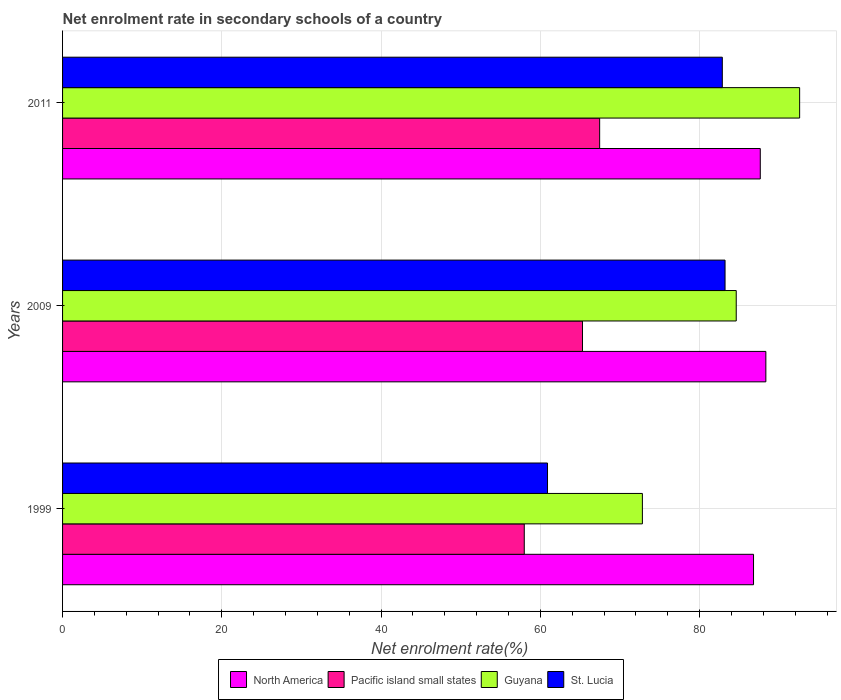How many different coloured bars are there?
Offer a terse response. 4. How many groups of bars are there?
Provide a succinct answer. 3. Are the number of bars per tick equal to the number of legend labels?
Ensure brevity in your answer.  Yes. What is the net enrolment rate in secondary schools in Guyana in 2009?
Offer a very short reply. 84.6. Across all years, what is the maximum net enrolment rate in secondary schools in North America?
Your answer should be very brief. 88.32. Across all years, what is the minimum net enrolment rate in secondary schools in Guyana?
Ensure brevity in your answer.  72.81. In which year was the net enrolment rate in secondary schools in North America minimum?
Your response must be concise. 1999. What is the total net enrolment rate in secondary schools in Guyana in the graph?
Your answer should be very brief. 249.98. What is the difference between the net enrolment rate in secondary schools in St. Lucia in 1999 and that in 2011?
Provide a succinct answer. -21.95. What is the difference between the net enrolment rate in secondary schools in Guyana in 2009 and the net enrolment rate in secondary schools in North America in 1999?
Ensure brevity in your answer.  -2.17. What is the average net enrolment rate in secondary schools in St. Lucia per year?
Provide a short and direct response. 75.65. In the year 2009, what is the difference between the net enrolment rate in secondary schools in Guyana and net enrolment rate in secondary schools in Pacific island small states?
Offer a terse response. 19.31. What is the ratio of the net enrolment rate in secondary schools in Pacific island small states in 1999 to that in 2011?
Your answer should be very brief. 0.86. What is the difference between the highest and the second highest net enrolment rate in secondary schools in Guyana?
Give a very brief answer. 7.96. What is the difference between the highest and the lowest net enrolment rate in secondary schools in St. Lucia?
Ensure brevity in your answer.  22.3. Is the sum of the net enrolment rate in secondary schools in North America in 1999 and 2011 greater than the maximum net enrolment rate in secondary schools in Guyana across all years?
Provide a short and direct response. Yes. What does the 3rd bar from the top in 2009 represents?
Keep it short and to the point. Pacific island small states. What does the 2nd bar from the bottom in 1999 represents?
Keep it short and to the point. Pacific island small states. Is it the case that in every year, the sum of the net enrolment rate in secondary schools in St. Lucia and net enrolment rate in secondary schools in Guyana is greater than the net enrolment rate in secondary schools in North America?
Provide a succinct answer. Yes. Are all the bars in the graph horizontal?
Give a very brief answer. Yes. Are the values on the major ticks of X-axis written in scientific E-notation?
Provide a short and direct response. No. Does the graph contain grids?
Your answer should be compact. Yes. Where does the legend appear in the graph?
Offer a very short reply. Bottom center. How many legend labels are there?
Make the answer very short. 4. What is the title of the graph?
Your response must be concise. Net enrolment rate in secondary schools of a country. What is the label or title of the X-axis?
Offer a terse response. Net enrolment rate(%). What is the Net enrolment rate(%) in North America in 1999?
Make the answer very short. 86.77. What is the Net enrolment rate(%) in Pacific island small states in 1999?
Your response must be concise. 57.98. What is the Net enrolment rate(%) in Guyana in 1999?
Your response must be concise. 72.81. What is the Net enrolment rate(%) in St. Lucia in 1999?
Provide a succinct answer. 60.9. What is the Net enrolment rate(%) of North America in 2009?
Ensure brevity in your answer.  88.32. What is the Net enrolment rate(%) of Pacific island small states in 2009?
Ensure brevity in your answer.  65.29. What is the Net enrolment rate(%) in Guyana in 2009?
Offer a terse response. 84.6. What is the Net enrolment rate(%) of St. Lucia in 2009?
Give a very brief answer. 83.2. What is the Net enrolment rate(%) of North America in 2011?
Give a very brief answer. 87.62. What is the Net enrolment rate(%) in Pacific island small states in 2011?
Give a very brief answer. 67.45. What is the Net enrolment rate(%) in Guyana in 2011?
Your answer should be very brief. 92.56. What is the Net enrolment rate(%) in St. Lucia in 2011?
Provide a short and direct response. 82.85. Across all years, what is the maximum Net enrolment rate(%) of North America?
Make the answer very short. 88.32. Across all years, what is the maximum Net enrolment rate(%) of Pacific island small states?
Offer a very short reply. 67.45. Across all years, what is the maximum Net enrolment rate(%) of Guyana?
Your answer should be very brief. 92.56. Across all years, what is the maximum Net enrolment rate(%) of St. Lucia?
Keep it short and to the point. 83.2. Across all years, what is the minimum Net enrolment rate(%) in North America?
Your answer should be very brief. 86.77. Across all years, what is the minimum Net enrolment rate(%) in Pacific island small states?
Offer a very short reply. 57.98. Across all years, what is the minimum Net enrolment rate(%) of Guyana?
Make the answer very short. 72.81. Across all years, what is the minimum Net enrolment rate(%) of St. Lucia?
Offer a very short reply. 60.9. What is the total Net enrolment rate(%) in North America in the graph?
Provide a short and direct response. 262.71. What is the total Net enrolment rate(%) of Pacific island small states in the graph?
Make the answer very short. 190.72. What is the total Net enrolment rate(%) of Guyana in the graph?
Your answer should be compact. 249.98. What is the total Net enrolment rate(%) of St. Lucia in the graph?
Your answer should be compact. 226.95. What is the difference between the Net enrolment rate(%) of North America in 1999 and that in 2009?
Offer a very short reply. -1.55. What is the difference between the Net enrolment rate(%) in Pacific island small states in 1999 and that in 2009?
Ensure brevity in your answer.  -7.31. What is the difference between the Net enrolment rate(%) in Guyana in 1999 and that in 2009?
Offer a very short reply. -11.79. What is the difference between the Net enrolment rate(%) in St. Lucia in 1999 and that in 2009?
Provide a short and direct response. -22.3. What is the difference between the Net enrolment rate(%) in North America in 1999 and that in 2011?
Keep it short and to the point. -0.85. What is the difference between the Net enrolment rate(%) in Pacific island small states in 1999 and that in 2011?
Your answer should be very brief. -9.47. What is the difference between the Net enrolment rate(%) of Guyana in 1999 and that in 2011?
Offer a terse response. -19.75. What is the difference between the Net enrolment rate(%) of St. Lucia in 1999 and that in 2011?
Offer a terse response. -21.95. What is the difference between the Net enrolment rate(%) in North America in 2009 and that in 2011?
Make the answer very short. 0.7. What is the difference between the Net enrolment rate(%) of Pacific island small states in 2009 and that in 2011?
Your answer should be very brief. -2.16. What is the difference between the Net enrolment rate(%) in Guyana in 2009 and that in 2011?
Your response must be concise. -7.96. What is the difference between the Net enrolment rate(%) in St. Lucia in 2009 and that in 2011?
Offer a very short reply. 0.34. What is the difference between the Net enrolment rate(%) of North America in 1999 and the Net enrolment rate(%) of Pacific island small states in 2009?
Offer a very short reply. 21.48. What is the difference between the Net enrolment rate(%) of North America in 1999 and the Net enrolment rate(%) of Guyana in 2009?
Make the answer very short. 2.17. What is the difference between the Net enrolment rate(%) of North America in 1999 and the Net enrolment rate(%) of St. Lucia in 2009?
Make the answer very short. 3.58. What is the difference between the Net enrolment rate(%) of Pacific island small states in 1999 and the Net enrolment rate(%) of Guyana in 2009?
Offer a terse response. -26.62. What is the difference between the Net enrolment rate(%) of Pacific island small states in 1999 and the Net enrolment rate(%) of St. Lucia in 2009?
Your response must be concise. -25.21. What is the difference between the Net enrolment rate(%) in Guyana in 1999 and the Net enrolment rate(%) in St. Lucia in 2009?
Your answer should be very brief. -10.38. What is the difference between the Net enrolment rate(%) in North America in 1999 and the Net enrolment rate(%) in Pacific island small states in 2011?
Give a very brief answer. 19.32. What is the difference between the Net enrolment rate(%) in North America in 1999 and the Net enrolment rate(%) in Guyana in 2011?
Give a very brief answer. -5.79. What is the difference between the Net enrolment rate(%) of North America in 1999 and the Net enrolment rate(%) of St. Lucia in 2011?
Offer a very short reply. 3.92. What is the difference between the Net enrolment rate(%) of Pacific island small states in 1999 and the Net enrolment rate(%) of Guyana in 2011?
Your answer should be compact. -34.58. What is the difference between the Net enrolment rate(%) of Pacific island small states in 1999 and the Net enrolment rate(%) of St. Lucia in 2011?
Provide a succinct answer. -24.87. What is the difference between the Net enrolment rate(%) in Guyana in 1999 and the Net enrolment rate(%) in St. Lucia in 2011?
Keep it short and to the point. -10.04. What is the difference between the Net enrolment rate(%) in North America in 2009 and the Net enrolment rate(%) in Pacific island small states in 2011?
Offer a terse response. 20.87. What is the difference between the Net enrolment rate(%) of North America in 2009 and the Net enrolment rate(%) of Guyana in 2011?
Offer a terse response. -4.24. What is the difference between the Net enrolment rate(%) in North America in 2009 and the Net enrolment rate(%) in St. Lucia in 2011?
Offer a very short reply. 5.47. What is the difference between the Net enrolment rate(%) in Pacific island small states in 2009 and the Net enrolment rate(%) in Guyana in 2011?
Provide a succinct answer. -27.27. What is the difference between the Net enrolment rate(%) of Pacific island small states in 2009 and the Net enrolment rate(%) of St. Lucia in 2011?
Your answer should be compact. -17.56. What is the difference between the Net enrolment rate(%) of Guyana in 2009 and the Net enrolment rate(%) of St. Lucia in 2011?
Your answer should be very brief. 1.75. What is the average Net enrolment rate(%) in North America per year?
Offer a very short reply. 87.57. What is the average Net enrolment rate(%) in Pacific island small states per year?
Provide a short and direct response. 63.57. What is the average Net enrolment rate(%) of Guyana per year?
Make the answer very short. 83.33. What is the average Net enrolment rate(%) in St. Lucia per year?
Provide a short and direct response. 75.65. In the year 1999, what is the difference between the Net enrolment rate(%) in North America and Net enrolment rate(%) in Pacific island small states?
Your answer should be compact. 28.79. In the year 1999, what is the difference between the Net enrolment rate(%) in North America and Net enrolment rate(%) in Guyana?
Your answer should be compact. 13.96. In the year 1999, what is the difference between the Net enrolment rate(%) in North America and Net enrolment rate(%) in St. Lucia?
Ensure brevity in your answer.  25.87. In the year 1999, what is the difference between the Net enrolment rate(%) of Pacific island small states and Net enrolment rate(%) of Guyana?
Provide a succinct answer. -14.83. In the year 1999, what is the difference between the Net enrolment rate(%) of Pacific island small states and Net enrolment rate(%) of St. Lucia?
Give a very brief answer. -2.92. In the year 1999, what is the difference between the Net enrolment rate(%) of Guyana and Net enrolment rate(%) of St. Lucia?
Give a very brief answer. 11.91. In the year 2009, what is the difference between the Net enrolment rate(%) of North America and Net enrolment rate(%) of Pacific island small states?
Make the answer very short. 23.03. In the year 2009, what is the difference between the Net enrolment rate(%) in North America and Net enrolment rate(%) in Guyana?
Your response must be concise. 3.72. In the year 2009, what is the difference between the Net enrolment rate(%) in North America and Net enrolment rate(%) in St. Lucia?
Offer a very short reply. 5.13. In the year 2009, what is the difference between the Net enrolment rate(%) of Pacific island small states and Net enrolment rate(%) of Guyana?
Your answer should be compact. -19.31. In the year 2009, what is the difference between the Net enrolment rate(%) of Pacific island small states and Net enrolment rate(%) of St. Lucia?
Provide a succinct answer. -17.9. In the year 2009, what is the difference between the Net enrolment rate(%) in Guyana and Net enrolment rate(%) in St. Lucia?
Ensure brevity in your answer.  1.41. In the year 2011, what is the difference between the Net enrolment rate(%) of North America and Net enrolment rate(%) of Pacific island small states?
Your response must be concise. 20.17. In the year 2011, what is the difference between the Net enrolment rate(%) in North America and Net enrolment rate(%) in Guyana?
Make the answer very short. -4.94. In the year 2011, what is the difference between the Net enrolment rate(%) of North America and Net enrolment rate(%) of St. Lucia?
Your answer should be very brief. 4.77. In the year 2011, what is the difference between the Net enrolment rate(%) in Pacific island small states and Net enrolment rate(%) in Guyana?
Make the answer very short. -25.11. In the year 2011, what is the difference between the Net enrolment rate(%) in Pacific island small states and Net enrolment rate(%) in St. Lucia?
Keep it short and to the point. -15.4. In the year 2011, what is the difference between the Net enrolment rate(%) in Guyana and Net enrolment rate(%) in St. Lucia?
Offer a very short reply. 9.71. What is the ratio of the Net enrolment rate(%) in North America in 1999 to that in 2009?
Keep it short and to the point. 0.98. What is the ratio of the Net enrolment rate(%) in Pacific island small states in 1999 to that in 2009?
Ensure brevity in your answer.  0.89. What is the ratio of the Net enrolment rate(%) of Guyana in 1999 to that in 2009?
Keep it short and to the point. 0.86. What is the ratio of the Net enrolment rate(%) in St. Lucia in 1999 to that in 2009?
Keep it short and to the point. 0.73. What is the ratio of the Net enrolment rate(%) of North America in 1999 to that in 2011?
Offer a very short reply. 0.99. What is the ratio of the Net enrolment rate(%) of Pacific island small states in 1999 to that in 2011?
Make the answer very short. 0.86. What is the ratio of the Net enrolment rate(%) of Guyana in 1999 to that in 2011?
Make the answer very short. 0.79. What is the ratio of the Net enrolment rate(%) of St. Lucia in 1999 to that in 2011?
Make the answer very short. 0.73. What is the ratio of the Net enrolment rate(%) in Pacific island small states in 2009 to that in 2011?
Make the answer very short. 0.97. What is the ratio of the Net enrolment rate(%) of Guyana in 2009 to that in 2011?
Give a very brief answer. 0.91. What is the difference between the highest and the second highest Net enrolment rate(%) of North America?
Offer a very short reply. 0.7. What is the difference between the highest and the second highest Net enrolment rate(%) of Pacific island small states?
Your answer should be compact. 2.16. What is the difference between the highest and the second highest Net enrolment rate(%) in Guyana?
Your response must be concise. 7.96. What is the difference between the highest and the second highest Net enrolment rate(%) of St. Lucia?
Your answer should be very brief. 0.34. What is the difference between the highest and the lowest Net enrolment rate(%) of North America?
Provide a short and direct response. 1.55. What is the difference between the highest and the lowest Net enrolment rate(%) of Pacific island small states?
Your answer should be compact. 9.47. What is the difference between the highest and the lowest Net enrolment rate(%) of Guyana?
Offer a terse response. 19.75. What is the difference between the highest and the lowest Net enrolment rate(%) of St. Lucia?
Your response must be concise. 22.3. 